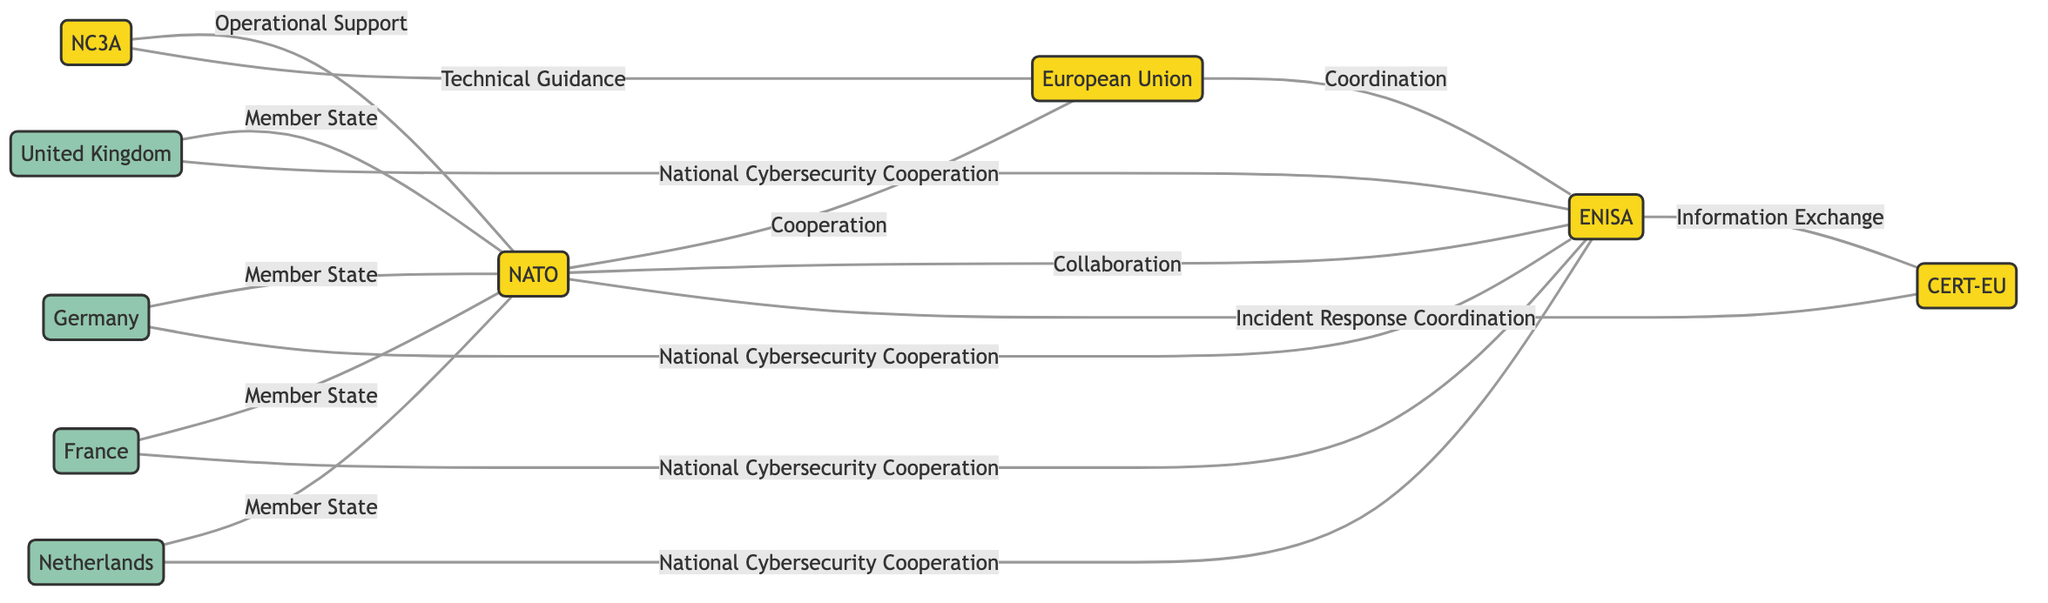What is the total number of nodes in the diagram? The nodes are NATO, EU, ENISA, CERT-EU, NC3A, UK, Germany, France, and Netherlands. By counting these distinct entities, we find there are 9 nodes in total.
Answer: 9 How many edges connect NATO and the European Union? There is one edge between NATO and the EU labeled "Cooperation". This counts as the only direct connection between these two nodes.
Answer: 1 What type of relationship exists between ENISA and CERT-EU? The edge connecting ENISA and CERT-EU is labeled "Information Exchange". This indicates a specific type of interaction related to sharing information.
Answer: Information Exchange Which organization provides Operational Support to NATO? The diagram shows an edge from NC3A to NATO labeled "Operational Support", indicating that NC3A is responsible for this function.
Answer: NC3A How many countries are represented as member states of NATO? The diagram shows four edges from UK, Germany, France, and Netherlands, all labeled "Member State", indicating that there are four member countries listed.
Answer: 4 What is the relationship between Germany and ENISA? The edge from Germany to ENISA is labeled "National Cybersecurity Cooperation", demonstrating that Germany collaborates with ENISA in that capacity.
Answer: National Cybersecurity Cooperation Which organization collaborates with both NATO and the European Union? The diagram indicates that NC3A collaborates with NATO (labeled "Operational Support") and also has an edge to EU (labeled "Technical Guidance"), thus fulfilling this criterion.
Answer: NC3A Identify the organization responsible for Incident Response Coordination concerning CERT-EU. The diagram shows an edge from NATO to CERT-EU with the label "Incident Response Coordination", clearly indicating that NATO is responsible for this aspect.
Answer: NATO What type of guidance is provided by NC3A to the European Union? The diagram illustrates an edge from NC3A to EU labeled "Technical Guidance", therefore conveying the specific type of support offered by NC3A.
Answer: Technical Guidance 